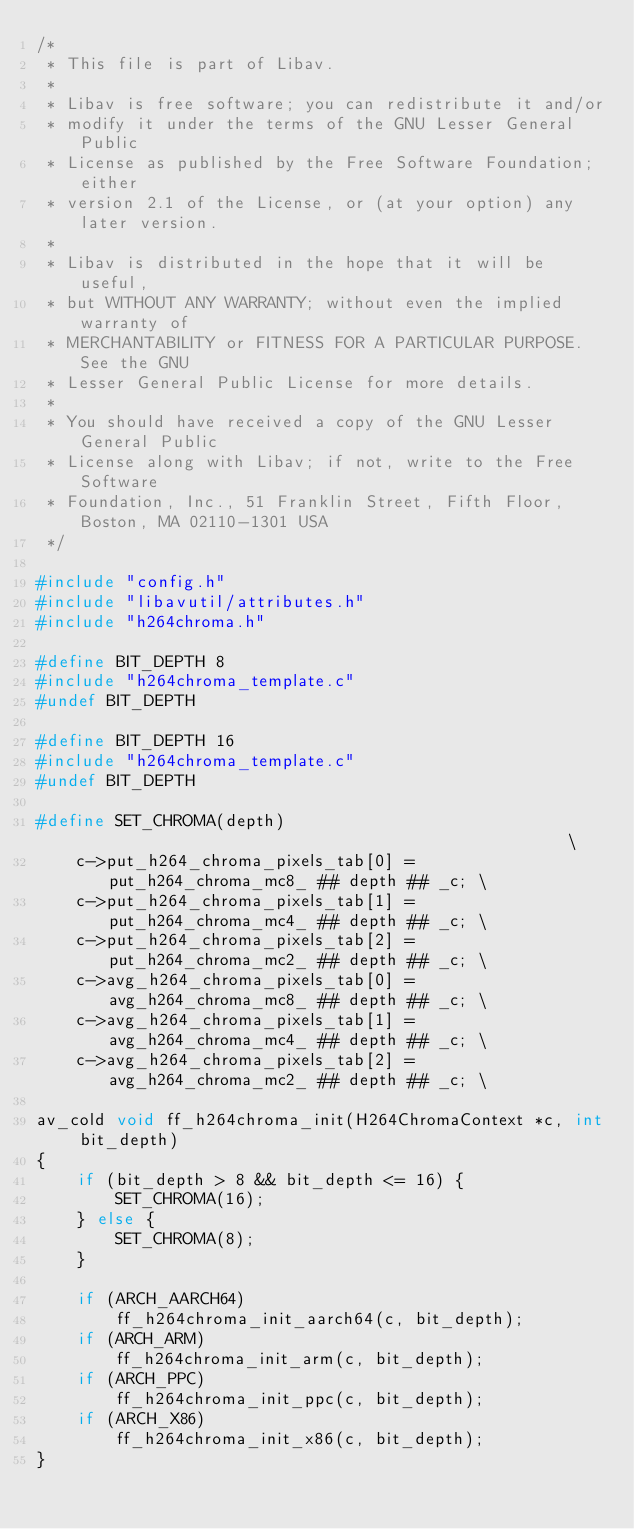Convert code to text. <code><loc_0><loc_0><loc_500><loc_500><_C_>/*
 * This file is part of Libav.
 *
 * Libav is free software; you can redistribute it and/or
 * modify it under the terms of the GNU Lesser General Public
 * License as published by the Free Software Foundation; either
 * version 2.1 of the License, or (at your option) any later version.
 *
 * Libav is distributed in the hope that it will be useful,
 * but WITHOUT ANY WARRANTY; without even the implied warranty of
 * MERCHANTABILITY or FITNESS FOR A PARTICULAR PURPOSE.  See the GNU
 * Lesser General Public License for more details.
 *
 * You should have received a copy of the GNU Lesser General Public
 * License along with Libav; if not, write to the Free Software
 * Foundation, Inc., 51 Franklin Street, Fifth Floor, Boston, MA 02110-1301 USA
 */

#include "config.h"
#include "libavutil/attributes.h"
#include "h264chroma.h"

#define BIT_DEPTH 8
#include "h264chroma_template.c"
#undef BIT_DEPTH

#define BIT_DEPTH 16
#include "h264chroma_template.c"
#undef BIT_DEPTH

#define SET_CHROMA(depth)                                                   \
    c->put_h264_chroma_pixels_tab[0] = put_h264_chroma_mc8_ ## depth ## _c; \
    c->put_h264_chroma_pixels_tab[1] = put_h264_chroma_mc4_ ## depth ## _c; \
    c->put_h264_chroma_pixels_tab[2] = put_h264_chroma_mc2_ ## depth ## _c; \
    c->avg_h264_chroma_pixels_tab[0] = avg_h264_chroma_mc8_ ## depth ## _c; \
    c->avg_h264_chroma_pixels_tab[1] = avg_h264_chroma_mc4_ ## depth ## _c; \
    c->avg_h264_chroma_pixels_tab[2] = avg_h264_chroma_mc2_ ## depth ## _c; \

av_cold void ff_h264chroma_init(H264ChromaContext *c, int bit_depth)
{
    if (bit_depth > 8 && bit_depth <= 16) {
        SET_CHROMA(16);
    } else {
        SET_CHROMA(8);
    }

    if (ARCH_AARCH64)
        ff_h264chroma_init_aarch64(c, bit_depth);
    if (ARCH_ARM)
        ff_h264chroma_init_arm(c, bit_depth);
    if (ARCH_PPC)
        ff_h264chroma_init_ppc(c, bit_depth);
    if (ARCH_X86)
        ff_h264chroma_init_x86(c, bit_depth);
}
</code> 